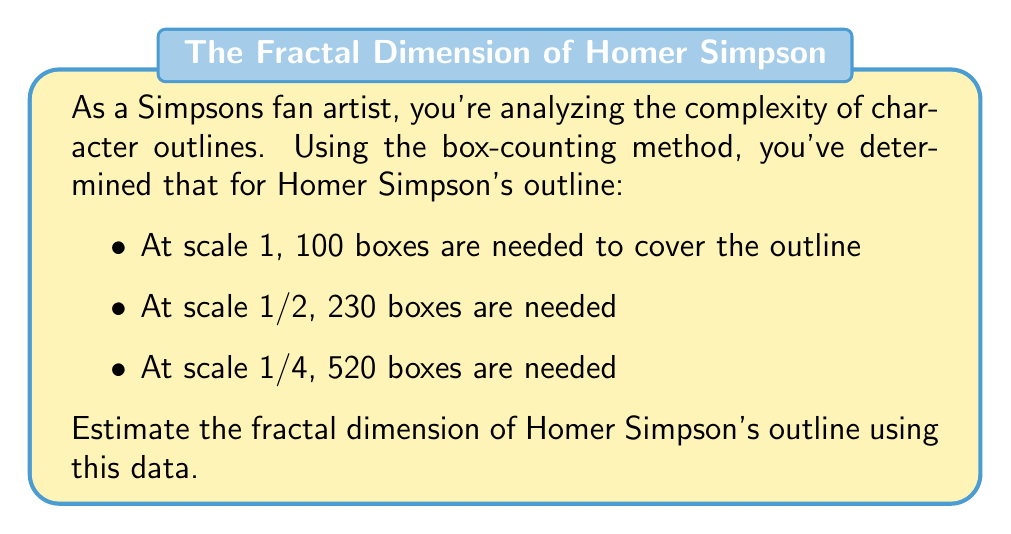Help me with this question. To estimate the fractal dimension using the box-counting method, we use the following steps:

1) The fractal dimension $D$ is given by the formula:

   $$D = \lim_{\epsilon \to 0} \frac{\log N(\epsilon)}{\log(1/\epsilon)}$$

   where $N(\epsilon)$ is the number of boxes of size $\epsilon$ needed to cover the outline.

2) We can estimate this by plotting $\log N(\epsilon)$ against $\log(1/\epsilon)$ and finding the slope of the best-fit line.

3) Let's organize our data:

   Scale ($\epsilon$) | $1/\epsilon$ | $N(\epsilon)$ | $\log(1/\epsilon)$ | $\log N(\epsilon)$
   ------------------|-------------|--------------|-------------------|------------------
   1                 | 1           | 100          | 0                 | $\log 100$
   1/2               | 2           | 230          | $\log 2$          | $\log 230$
   1/4               | 4           | 520          | $\log 4$          | $\log 520$

4) Now, we can use the slope formula:

   $$D \approx \frac{\log N(\epsilon_2) - \log N(\epsilon_1)}{\log(1/\epsilon_2) - \log(1/\epsilon_1)}$$

5) Let's use the first and last data points:

   $$D \approx \frac{\log 520 - \log 100}{\log 4 - \log 1} = \frac{\log 520 - \log 100}{\log 4}$$

6) Calculating this:

   $$D \approx \frac{6.2538 - 4.6052}{1.3863} \approx 1.1892$$

Therefore, the estimated fractal dimension of Homer Simpson's outline is approximately 1.1892.
Answer: $D \approx 1.1892$ 